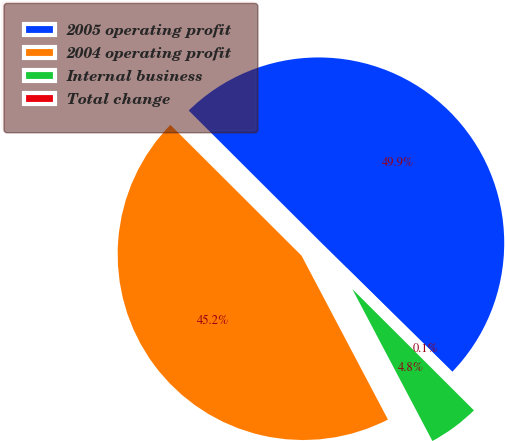<chart> <loc_0><loc_0><loc_500><loc_500><pie_chart><fcel>2005 operating profit<fcel>2004 operating profit<fcel>Internal business<fcel>Total change<nl><fcel>49.89%<fcel>45.2%<fcel>4.8%<fcel>0.11%<nl></chart> 